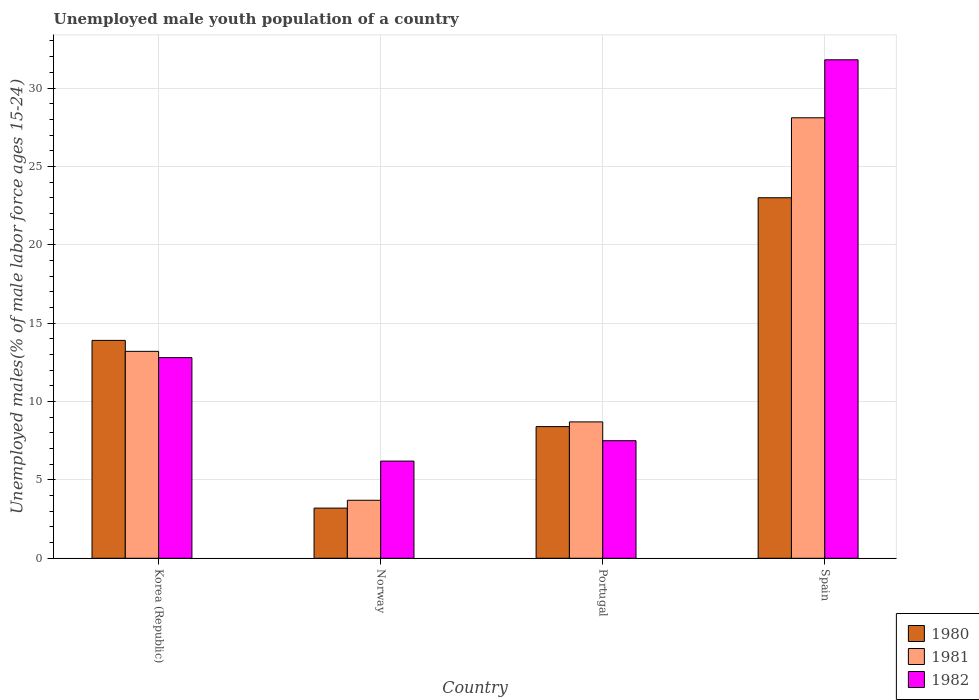How many different coloured bars are there?
Give a very brief answer. 3. How many bars are there on the 2nd tick from the left?
Provide a succinct answer. 3. In how many cases, is the number of bars for a given country not equal to the number of legend labels?
Give a very brief answer. 0. What is the percentage of unemployed male youth population in 1981 in Portugal?
Ensure brevity in your answer.  8.7. Across all countries, what is the maximum percentage of unemployed male youth population in 1982?
Offer a terse response. 31.8. Across all countries, what is the minimum percentage of unemployed male youth population in 1981?
Keep it short and to the point. 3.7. In which country was the percentage of unemployed male youth population in 1982 minimum?
Offer a terse response. Norway. What is the total percentage of unemployed male youth population in 1980 in the graph?
Provide a short and direct response. 48.5. What is the difference between the percentage of unemployed male youth population in 1980 in Korea (Republic) and that in Portugal?
Give a very brief answer. 5.5. What is the difference between the percentage of unemployed male youth population in 1981 in Portugal and the percentage of unemployed male youth population in 1980 in Korea (Republic)?
Make the answer very short. -5.2. What is the average percentage of unemployed male youth population in 1982 per country?
Give a very brief answer. 14.57. What is the difference between the percentage of unemployed male youth population of/in 1981 and percentage of unemployed male youth population of/in 1980 in Portugal?
Keep it short and to the point. 0.3. In how many countries, is the percentage of unemployed male youth population in 1982 greater than 28 %?
Your answer should be compact. 1. What is the ratio of the percentage of unemployed male youth population in 1981 in Korea (Republic) to that in Norway?
Offer a terse response. 3.57. Is the percentage of unemployed male youth population in 1981 in Norway less than that in Portugal?
Keep it short and to the point. Yes. Is the difference between the percentage of unemployed male youth population in 1981 in Norway and Spain greater than the difference between the percentage of unemployed male youth population in 1980 in Norway and Spain?
Your answer should be compact. No. What is the difference between the highest and the second highest percentage of unemployed male youth population in 1980?
Keep it short and to the point. -5.5. What is the difference between the highest and the lowest percentage of unemployed male youth population in 1982?
Your response must be concise. 25.6. In how many countries, is the percentage of unemployed male youth population in 1980 greater than the average percentage of unemployed male youth population in 1980 taken over all countries?
Offer a terse response. 2. What does the 2nd bar from the left in Portugal represents?
Keep it short and to the point. 1981. What does the 2nd bar from the right in Portugal represents?
Offer a very short reply. 1981. How many bars are there?
Ensure brevity in your answer.  12. Are all the bars in the graph horizontal?
Your answer should be compact. No. How many countries are there in the graph?
Your answer should be very brief. 4. What is the difference between two consecutive major ticks on the Y-axis?
Keep it short and to the point. 5. Are the values on the major ticks of Y-axis written in scientific E-notation?
Your answer should be very brief. No. Does the graph contain grids?
Your answer should be compact. Yes. Where does the legend appear in the graph?
Make the answer very short. Bottom right. How many legend labels are there?
Provide a short and direct response. 3. How are the legend labels stacked?
Make the answer very short. Vertical. What is the title of the graph?
Your answer should be very brief. Unemployed male youth population of a country. What is the label or title of the Y-axis?
Your answer should be compact. Unemployed males(% of male labor force ages 15-24). What is the Unemployed males(% of male labor force ages 15-24) of 1980 in Korea (Republic)?
Give a very brief answer. 13.9. What is the Unemployed males(% of male labor force ages 15-24) of 1981 in Korea (Republic)?
Your answer should be very brief. 13.2. What is the Unemployed males(% of male labor force ages 15-24) in 1982 in Korea (Republic)?
Provide a short and direct response. 12.8. What is the Unemployed males(% of male labor force ages 15-24) in 1980 in Norway?
Offer a very short reply. 3.2. What is the Unemployed males(% of male labor force ages 15-24) in 1981 in Norway?
Make the answer very short. 3.7. What is the Unemployed males(% of male labor force ages 15-24) in 1982 in Norway?
Keep it short and to the point. 6.2. What is the Unemployed males(% of male labor force ages 15-24) in 1980 in Portugal?
Ensure brevity in your answer.  8.4. What is the Unemployed males(% of male labor force ages 15-24) in 1981 in Portugal?
Provide a short and direct response. 8.7. What is the Unemployed males(% of male labor force ages 15-24) of 1982 in Portugal?
Your answer should be compact. 7.5. What is the Unemployed males(% of male labor force ages 15-24) in 1980 in Spain?
Offer a terse response. 23. What is the Unemployed males(% of male labor force ages 15-24) in 1981 in Spain?
Your answer should be very brief. 28.1. What is the Unemployed males(% of male labor force ages 15-24) of 1982 in Spain?
Provide a short and direct response. 31.8. Across all countries, what is the maximum Unemployed males(% of male labor force ages 15-24) in 1980?
Provide a short and direct response. 23. Across all countries, what is the maximum Unemployed males(% of male labor force ages 15-24) in 1981?
Give a very brief answer. 28.1. Across all countries, what is the maximum Unemployed males(% of male labor force ages 15-24) of 1982?
Make the answer very short. 31.8. Across all countries, what is the minimum Unemployed males(% of male labor force ages 15-24) in 1980?
Keep it short and to the point. 3.2. Across all countries, what is the minimum Unemployed males(% of male labor force ages 15-24) of 1981?
Provide a short and direct response. 3.7. Across all countries, what is the minimum Unemployed males(% of male labor force ages 15-24) of 1982?
Offer a terse response. 6.2. What is the total Unemployed males(% of male labor force ages 15-24) of 1980 in the graph?
Your answer should be compact. 48.5. What is the total Unemployed males(% of male labor force ages 15-24) in 1981 in the graph?
Ensure brevity in your answer.  53.7. What is the total Unemployed males(% of male labor force ages 15-24) in 1982 in the graph?
Offer a terse response. 58.3. What is the difference between the Unemployed males(% of male labor force ages 15-24) of 1982 in Korea (Republic) and that in Norway?
Provide a short and direct response. 6.6. What is the difference between the Unemployed males(% of male labor force ages 15-24) of 1982 in Korea (Republic) and that in Portugal?
Offer a terse response. 5.3. What is the difference between the Unemployed males(% of male labor force ages 15-24) in 1981 in Korea (Republic) and that in Spain?
Your response must be concise. -14.9. What is the difference between the Unemployed males(% of male labor force ages 15-24) in 1980 in Norway and that in Portugal?
Offer a terse response. -5.2. What is the difference between the Unemployed males(% of male labor force ages 15-24) in 1980 in Norway and that in Spain?
Make the answer very short. -19.8. What is the difference between the Unemployed males(% of male labor force ages 15-24) of 1981 in Norway and that in Spain?
Provide a short and direct response. -24.4. What is the difference between the Unemployed males(% of male labor force ages 15-24) in 1982 in Norway and that in Spain?
Keep it short and to the point. -25.6. What is the difference between the Unemployed males(% of male labor force ages 15-24) of 1980 in Portugal and that in Spain?
Make the answer very short. -14.6. What is the difference between the Unemployed males(% of male labor force ages 15-24) in 1981 in Portugal and that in Spain?
Offer a terse response. -19.4. What is the difference between the Unemployed males(% of male labor force ages 15-24) of 1982 in Portugal and that in Spain?
Your answer should be compact. -24.3. What is the difference between the Unemployed males(% of male labor force ages 15-24) of 1980 in Korea (Republic) and the Unemployed males(% of male labor force ages 15-24) of 1982 in Norway?
Make the answer very short. 7.7. What is the difference between the Unemployed males(% of male labor force ages 15-24) of 1981 in Korea (Republic) and the Unemployed males(% of male labor force ages 15-24) of 1982 in Norway?
Give a very brief answer. 7. What is the difference between the Unemployed males(% of male labor force ages 15-24) of 1980 in Korea (Republic) and the Unemployed males(% of male labor force ages 15-24) of 1982 in Portugal?
Your response must be concise. 6.4. What is the difference between the Unemployed males(% of male labor force ages 15-24) in 1980 in Korea (Republic) and the Unemployed males(% of male labor force ages 15-24) in 1982 in Spain?
Your answer should be very brief. -17.9. What is the difference between the Unemployed males(% of male labor force ages 15-24) of 1981 in Korea (Republic) and the Unemployed males(% of male labor force ages 15-24) of 1982 in Spain?
Offer a terse response. -18.6. What is the difference between the Unemployed males(% of male labor force ages 15-24) in 1980 in Norway and the Unemployed males(% of male labor force ages 15-24) in 1981 in Spain?
Your response must be concise. -24.9. What is the difference between the Unemployed males(% of male labor force ages 15-24) of 1980 in Norway and the Unemployed males(% of male labor force ages 15-24) of 1982 in Spain?
Your answer should be compact. -28.6. What is the difference between the Unemployed males(% of male labor force ages 15-24) of 1981 in Norway and the Unemployed males(% of male labor force ages 15-24) of 1982 in Spain?
Your answer should be very brief. -28.1. What is the difference between the Unemployed males(% of male labor force ages 15-24) of 1980 in Portugal and the Unemployed males(% of male labor force ages 15-24) of 1981 in Spain?
Your answer should be compact. -19.7. What is the difference between the Unemployed males(% of male labor force ages 15-24) in 1980 in Portugal and the Unemployed males(% of male labor force ages 15-24) in 1982 in Spain?
Ensure brevity in your answer.  -23.4. What is the difference between the Unemployed males(% of male labor force ages 15-24) in 1981 in Portugal and the Unemployed males(% of male labor force ages 15-24) in 1982 in Spain?
Your answer should be compact. -23.1. What is the average Unemployed males(% of male labor force ages 15-24) of 1980 per country?
Offer a very short reply. 12.12. What is the average Unemployed males(% of male labor force ages 15-24) in 1981 per country?
Your answer should be compact. 13.43. What is the average Unemployed males(% of male labor force ages 15-24) of 1982 per country?
Provide a succinct answer. 14.57. What is the difference between the Unemployed males(% of male labor force ages 15-24) in 1980 and Unemployed males(% of male labor force ages 15-24) in 1981 in Korea (Republic)?
Make the answer very short. 0.7. What is the difference between the Unemployed males(% of male labor force ages 15-24) in 1980 and Unemployed males(% of male labor force ages 15-24) in 1982 in Norway?
Ensure brevity in your answer.  -3. What is the difference between the Unemployed males(% of male labor force ages 15-24) in 1980 and Unemployed males(% of male labor force ages 15-24) in 1981 in Portugal?
Ensure brevity in your answer.  -0.3. What is the difference between the Unemployed males(% of male labor force ages 15-24) of 1980 and Unemployed males(% of male labor force ages 15-24) of 1981 in Spain?
Give a very brief answer. -5.1. What is the difference between the Unemployed males(% of male labor force ages 15-24) in 1980 and Unemployed males(% of male labor force ages 15-24) in 1982 in Spain?
Provide a short and direct response. -8.8. What is the difference between the Unemployed males(% of male labor force ages 15-24) in 1981 and Unemployed males(% of male labor force ages 15-24) in 1982 in Spain?
Ensure brevity in your answer.  -3.7. What is the ratio of the Unemployed males(% of male labor force ages 15-24) in 1980 in Korea (Republic) to that in Norway?
Offer a very short reply. 4.34. What is the ratio of the Unemployed males(% of male labor force ages 15-24) in 1981 in Korea (Republic) to that in Norway?
Offer a terse response. 3.57. What is the ratio of the Unemployed males(% of male labor force ages 15-24) in 1982 in Korea (Republic) to that in Norway?
Offer a terse response. 2.06. What is the ratio of the Unemployed males(% of male labor force ages 15-24) of 1980 in Korea (Republic) to that in Portugal?
Provide a short and direct response. 1.65. What is the ratio of the Unemployed males(% of male labor force ages 15-24) of 1981 in Korea (Republic) to that in Portugal?
Provide a short and direct response. 1.52. What is the ratio of the Unemployed males(% of male labor force ages 15-24) in 1982 in Korea (Republic) to that in Portugal?
Make the answer very short. 1.71. What is the ratio of the Unemployed males(% of male labor force ages 15-24) in 1980 in Korea (Republic) to that in Spain?
Give a very brief answer. 0.6. What is the ratio of the Unemployed males(% of male labor force ages 15-24) of 1981 in Korea (Republic) to that in Spain?
Provide a short and direct response. 0.47. What is the ratio of the Unemployed males(% of male labor force ages 15-24) in 1982 in Korea (Republic) to that in Spain?
Make the answer very short. 0.4. What is the ratio of the Unemployed males(% of male labor force ages 15-24) of 1980 in Norway to that in Portugal?
Ensure brevity in your answer.  0.38. What is the ratio of the Unemployed males(% of male labor force ages 15-24) in 1981 in Norway to that in Portugal?
Ensure brevity in your answer.  0.43. What is the ratio of the Unemployed males(% of male labor force ages 15-24) of 1982 in Norway to that in Portugal?
Your response must be concise. 0.83. What is the ratio of the Unemployed males(% of male labor force ages 15-24) of 1980 in Norway to that in Spain?
Make the answer very short. 0.14. What is the ratio of the Unemployed males(% of male labor force ages 15-24) of 1981 in Norway to that in Spain?
Ensure brevity in your answer.  0.13. What is the ratio of the Unemployed males(% of male labor force ages 15-24) of 1982 in Norway to that in Spain?
Ensure brevity in your answer.  0.2. What is the ratio of the Unemployed males(% of male labor force ages 15-24) in 1980 in Portugal to that in Spain?
Your answer should be compact. 0.37. What is the ratio of the Unemployed males(% of male labor force ages 15-24) of 1981 in Portugal to that in Spain?
Make the answer very short. 0.31. What is the ratio of the Unemployed males(% of male labor force ages 15-24) in 1982 in Portugal to that in Spain?
Your answer should be compact. 0.24. What is the difference between the highest and the second highest Unemployed males(% of male labor force ages 15-24) of 1980?
Offer a terse response. 9.1. What is the difference between the highest and the second highest Unemployed males(% of male labor force ages 15-24) in 1982?
Your response must be concise. 19. What is the difference between the highest and the lowest Unemployed males(% of male labor force ages 15-24) of 1980?
Provide a short and direct response. 19.8. What is the difference between the highest and the lowest Unemployed males(% of male labor force ages 15-24) of 1981?
Ensure brevity in your answer.  24.4. What is the difference between the highest and the lowest Unemployed males(% of male labor force ages 15-24) in 1982?
Provide a succinct answer. 25.6. 